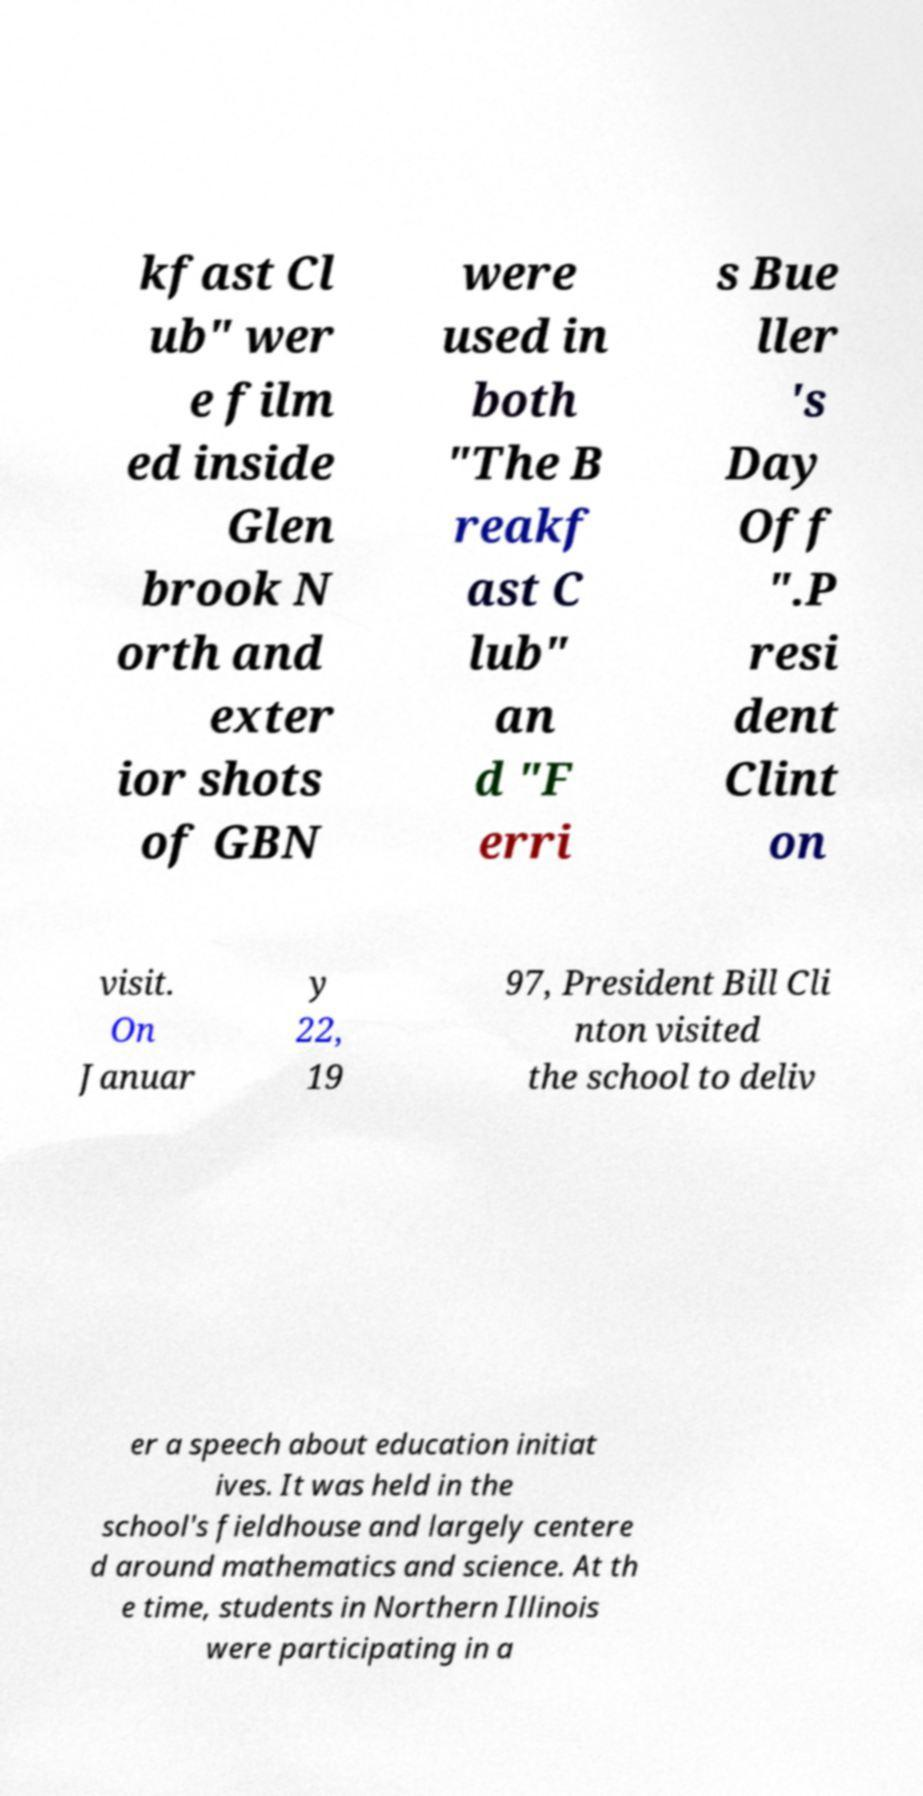There's text embedded in this image that I need extracted. Can you transcribe it verbatim? kfast Cl ub" wer e film ed inside Glen brook N orth and exter ior shots of GBN were used in both "The B reakf ast C lub" an d "F erri s Bue ller 's Day Off ".P resi dent Clint on visit. On Januar y 22, 19 97, President Bill Cli nton visited the school to deliv er a speech about education initiat ives. It was held in the school's fieldhouse and largely centere d around mathematics and science. At th e time, students in Northern Illinois were participating in a 